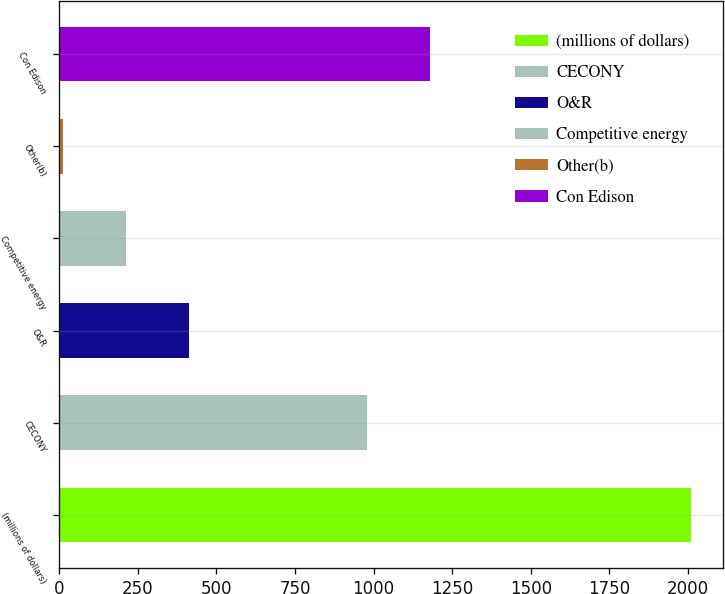<chart> <loc_0><loc_0><loc_500><loc_500><bar_chart><fcel>(millions of dollars)<fcel>CECONY<fcel>O&R<fcel>Competitive energy<fcel>Other(b)<fcel>Con Edison<nl><fcel>2011<fcel>978<fcel>411.8<fcel>211.9<fcel>12<fcel>1177.9<nl></chart> 